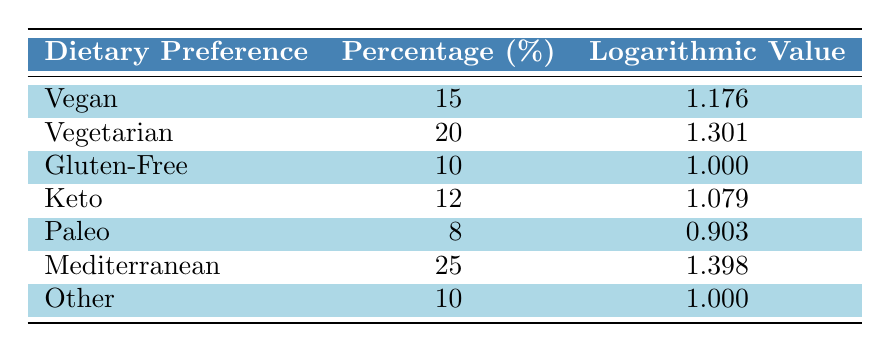What is the percentage of customers who prefer a Mediterranean diet? The table lists the Mediterranean dietary preference with a corresponding percentage. By locating this row, we find the percentage is 25%.
Answer: 25% Which dietary preference has the lowest percentage? By examining the percentages in the table, we see that the Paleo preference has the lowest percentage at 8%.
Answer: 8% Is there a dietary preference that 10% of customers choose? The table indicates that both Gluten-Free and Other dietary preferences have a percentage of 10%. Therefore, the answer is yes.
Answer: Yes What is the difference in percentage between Vegetarian and Vegan preferences? Looking at the percentages for Vegetarian (20%) and Vegan (15%), the difference is 20% - 15% = 5%.
Answer: 5% Calculate the average percentage of all dietary preferences listed in the table. To find the average, sum the percentages: 15 + 20 + 10 + 12 + 8 + 25 + 10 = 100. There are 7 preferences, so the average is 100/7 ≈ 14.29%.
Answer: 14.29% How many dietary preferences have a logarithmic value greater than 1.1? Checking the logarithmic values, we see Vegan (1.176), Vegetarian (1.301), and Mediterranean (1.398) all exceed 1.1. Thus, there are three preferences.
Answer: 3 Is the percentage of customers preferring a Keto diet greater than that of those preferring a Gluten-Free diet? The Keto preference is at 12%, while the Gluten-Free preference is at 10%. Since 12% > 10%, the answer is yes.
Answer: Yes What is the sum of the percentages for Vegan and Paleo diets? The percentage of Vegan is 15% and Paleo is 8%. Adding these gives us 15 + 8 = 23%.
Answer: 23% Which dietary preference has the highest logarithmic value and what is that value? By checking the logarithmic values, Mediterranean has the highest at 1.398.
Answer: 1.398 